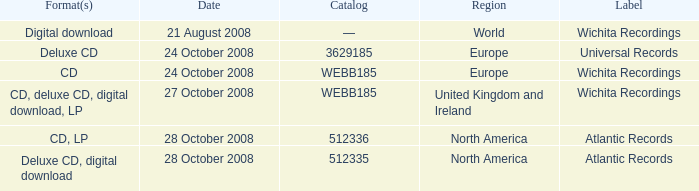What are the formats associated with the Atlantic Records label, catalog number 512336? CD, LP. 